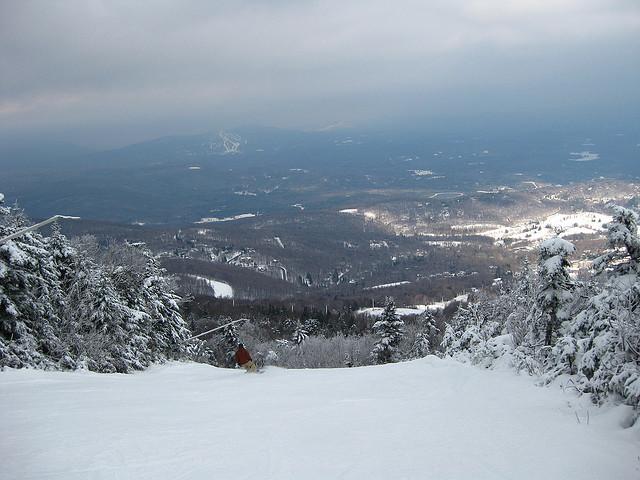What season is it?
Be succinct. Winter. Can you ski here?
Give a very brief answer. Yes. Is the sky clear?
Give a very brief answer. No. 